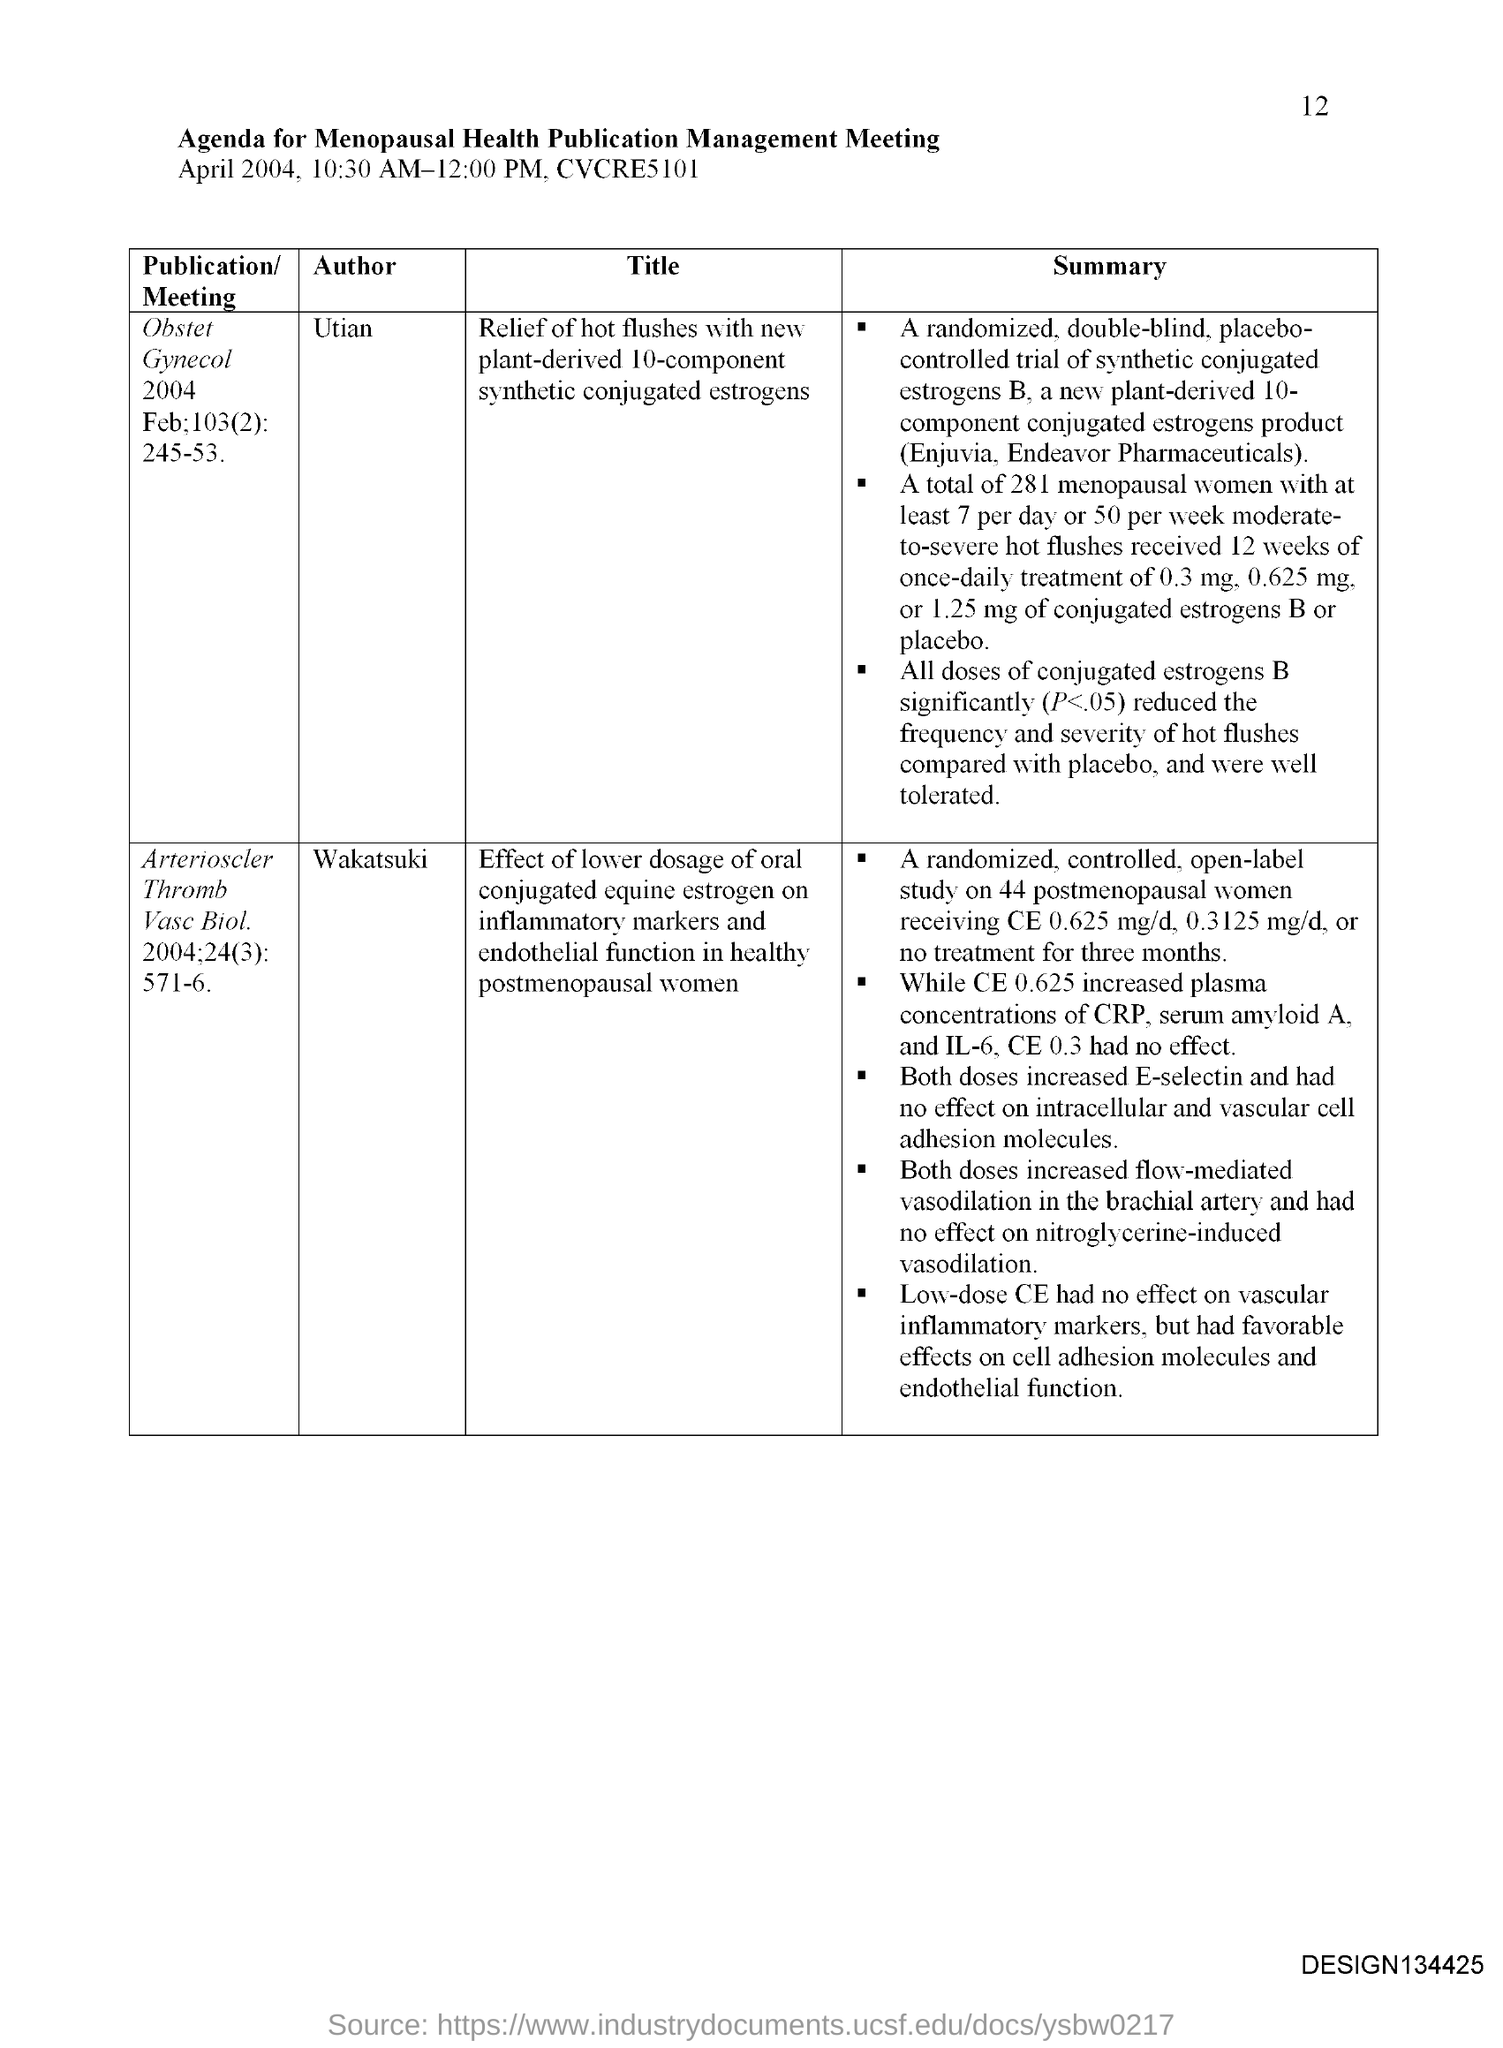Highlight a few significant elements in this photo. The Menopausal Health Publication Management Meeting is scheduled to take place on April 2004, from 10:30 AM to 12:00 PM. The page number mentioned in this document is 12. 